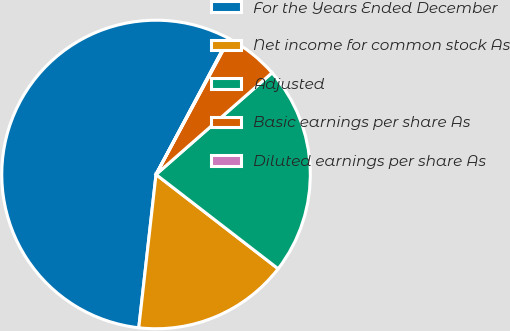Convert chart. <chart><loc_0><loc_0><loc_500><loc_500><pie_chart><fcel>For the Years Ended December<fcel>Net income for common stock As<fcel>Adjusted<fcel>Basic earnings per share As<fcel>Diluted earnings per share As<nl><fcel>56.01%<fcel>16.32%<fcel>21.92%<fcel>5.67%<fcel>0.08%<nl></chart> 